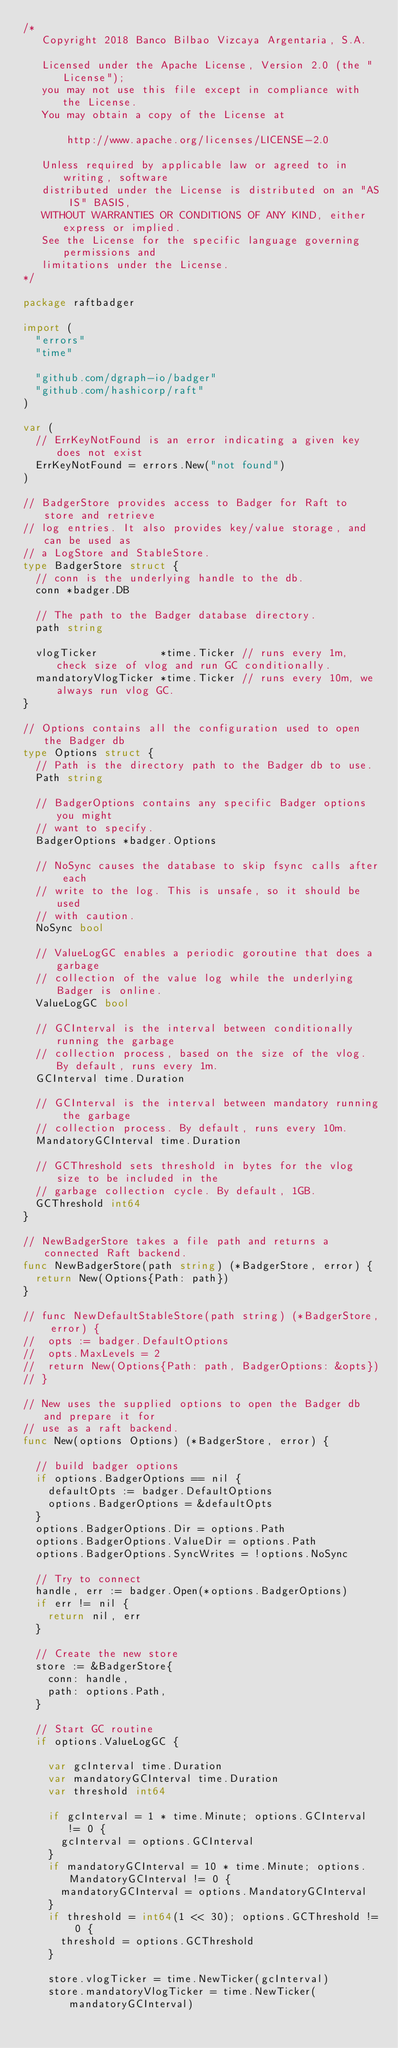<code> <loc_0><loc_0><loc_500><loc_500><_Go_>/*
   Copyright 2018 Banco Bilbao Vizcaya Argentaria, S.A.

   Licensed under the Apache License, Version 2.0 (the "License");
   you may not use this file except in compliance with the License.
   You may obtain a copy of the License at

       http://www.apache.org/licenses/LICENSE-2.0

   Unless required by applicable law or agreed to in writing, software
   distributed under the License is distributed on an "AS IS" BASIS,
   WITHOUT WARRANTIES OR CONDITIONS OF ANY KIND, either express or implied.
   See the License for the specific language governing permissions and
   limitations under the License.
*/

package raftbadger

import (
	"errors"
	"time"

	"github.com/dgraph-io/badger"
	"github.com/hashicorp/raft"
)

var (
	// ErrKeyNotFound is an error indicating a given key does not exist
	ErrKeyNotFound = errors.New("not found")
)

// BadgerStore provides access to Badger for Raft to store and retrieve
// log entries. It also provides key/value storage, and can be used as
// a LogStore and StableStore.
type BadgerStore struct {
	// conn is the underlying handle to the db.
	conn *badger.DB

	// The path to the Badger database directory.
	path string

	vlogTicker          *time.Ticker // runs every 1m, check size of vlog and run GC conditionally.
	mandatoryVlogTicker *time.Ticker // runs every 10m, we always run vlog GC.
}

// Options contains all the configuration used to open the Badger db
type Options struct {
	// Path is the directory path to the Badger db to use.
	Path string

	// BadgerOptions contains any specific Badger options you might
	// want to specify.
	BadgerOptions *badger.Options

	// NoSync causes the database to skip fsync calls after each
	// write to the log. This is unsafe, so it should be used
	// with caution.
	NoSync bool

	// ValueLogGC enables a periodic goroutine that does a garbage
	// collection of the value log while the underlying Badger is online.
	ValueLogGC bool

	// GCInterval is the interval between conditionally running the garbage
	// collection process, based on the size of the vlog. By default, runs every 1m.
	GCInterval time.Duration

	// GCInterval is the interval between mandatory running the garbage
	// collection process. By default, runs every 10m.
	MandatoryGCInterval time.Duration

	// GCThreshold sets threshold in bytes for the vlog size to be included in the
	// garbage collection cycle. By default, 1GB.
	GCThreshold int64
}

// NewBadgerStore takes a file path and returns a connected Raft backend.
func NewBadgerStore(path string) (*BadgerStore, error) {
	return New(Options{Path: path})
}

// func NewDefaultStableStore(path string) (*BadgerStore, error) {
// 	opts := badger.DefaultOptions
// 	opts.MaxLevels = 2
// 	return New(Options{Path: path, BadgerOptions: &opts})
// }

// New uses the supplied options to open the Badger db and prepare it for
// use as a raft backend.
func New(options Options) (*BadgerStore, error) {

	// build badger options
	if options.BadgerOptions == nil {
		defaultOpts := badger.DefaultOptions
		options.BadgerOptions = &defaultOpts
	}
	options.BadgerOptions.Dir = options.Path
	options.BadgerOptions.ValueDir = options.Path
	options.BadgerOptions.SyncWrites = !options.NoSync

	// Try to connect
	handle, err := badger.Open(*options.BadgerOptions)
	if err != nil {
		return nil, err
	}

	// Create the new store
	store := &BadgerStore{
		conn: handle,
		path: options.Path,
	}

	// Start GC routine
	if options.ValueLogGC {

		var gcInterval time.Duration
		var mandatoryGCInterval time.Duration
		var threshold int64

		if gcInterval = 1 * time.Minute; options.GCInterval != 0 {
			gcInterval = options.GCInterval
		}
		if mandatoryGCInterval = 10 * time.Minute; options.MandatoryGCInterval != 0 {
			mandatoryGCInterval = options.MandatoryGCInterval
		}
		if threshold = int64(1 << 30); options.GCThreshold != 0 {
			threshold = options.GCThreshold
		}

		store.vlogTicker = time.NewTicker(gcInterval)
		store.mandatoryVlogTicker = time.NewTicker(mandatoryGCInterval)</code> 